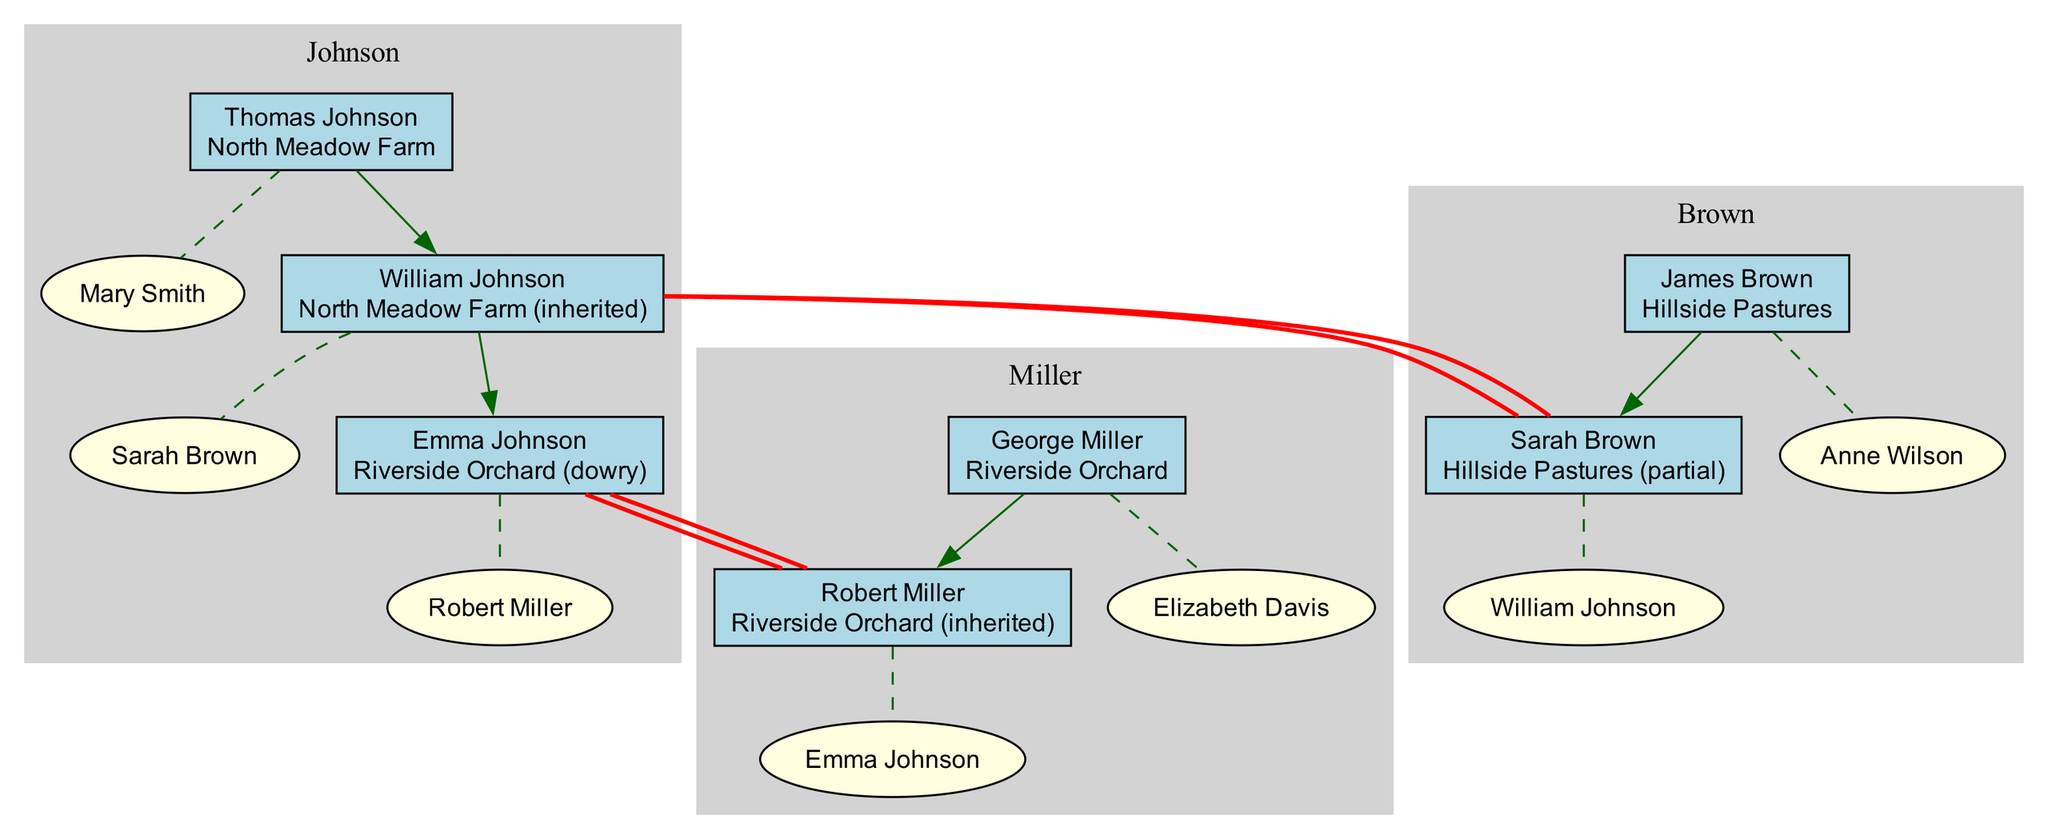What is the land owned by Thomas Johnson? The diagram displays Thomas Johnson's node, which shows that he owns "North Meadow Farm."
Answer: North Meadow Farm Who is the spouse of Emma Johnson? By examining Emma Johnson's node, we find that her spouse is "Robert Miller."
Answer: Robert Miller How many families are represented in the diagram? The diagram consists of three families: Johnson, Miller, and Brown. Counting these gives us a total of three families.
Answer: 3 Which land was inherited by William Johnson? The diagram indicates that William Johnson inherited "North Meadow Farm." This can be confirmed by looking at his node's land description.
Answer: North Meadow Farm (inherited) Is there an intermarriage between the Johnson and Miller families? We need to check for connections between the Johnson and Miller families' nodes. Emma Johnson is married to Robert Miller, indicating that there is indeed an intermarriage.
Answer: Yes What is the relationship between Sarah Brown and William Johnson? From the diagram, Sarah Brown is identified as a spouse of William Johnson, which categorizes them as husband and wife.
Answer: Husband and wife What land does Sarah Brown have a claim to? By looking at Sarah Brown's node, we see that she claims "Hillside Pastures (partial)" as her land.
Answer: Hillside Pastures (partial) How many generations are there in the Johnson family? The Johnson family has three generations shown in the diagram: Thomas Johnson, William Johnson, and Emma Johnson, which totals three generations.
Answer: 3 What type of land did Emma Johnson receive as a dowry? The diagram indicates that Emma Johnson received the "Riverside Orchard" as her dowry, which is clearly marked next to her name.
Answer: Riverside Orchard (dowry) 